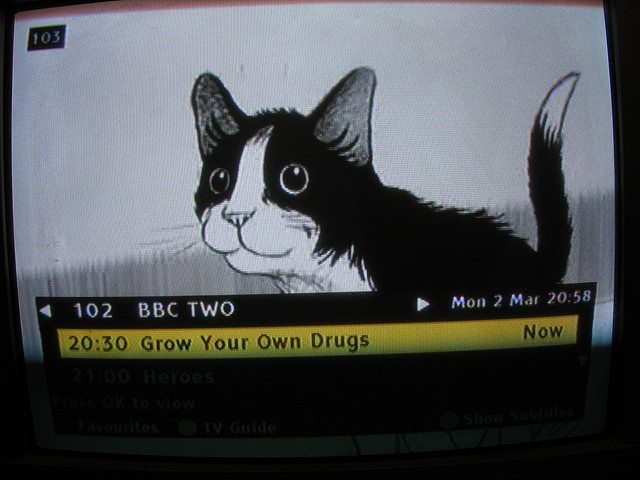Describe the objects in this image and their specific colors. I can see tv in black, darkgray, and gray tones and cat in black, darkgray, and gray tones in this image. 